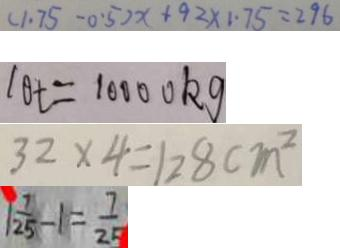<formula> <loc_0><loc_0><loc_500><loc_500>( 1 . 7 5 - 0 . 5 ) x + 9 2 \times 1 . 7 5 = 2 9 6 
 1 0 t = 1 0 0 0 0 k g 
 3 2 \times 4 = 1 2 8 c m ^ { 2 } 
 1 \frac { 7 } { 2 5 } - 1 = \frac { 7 } { 2 5 }</formula> 